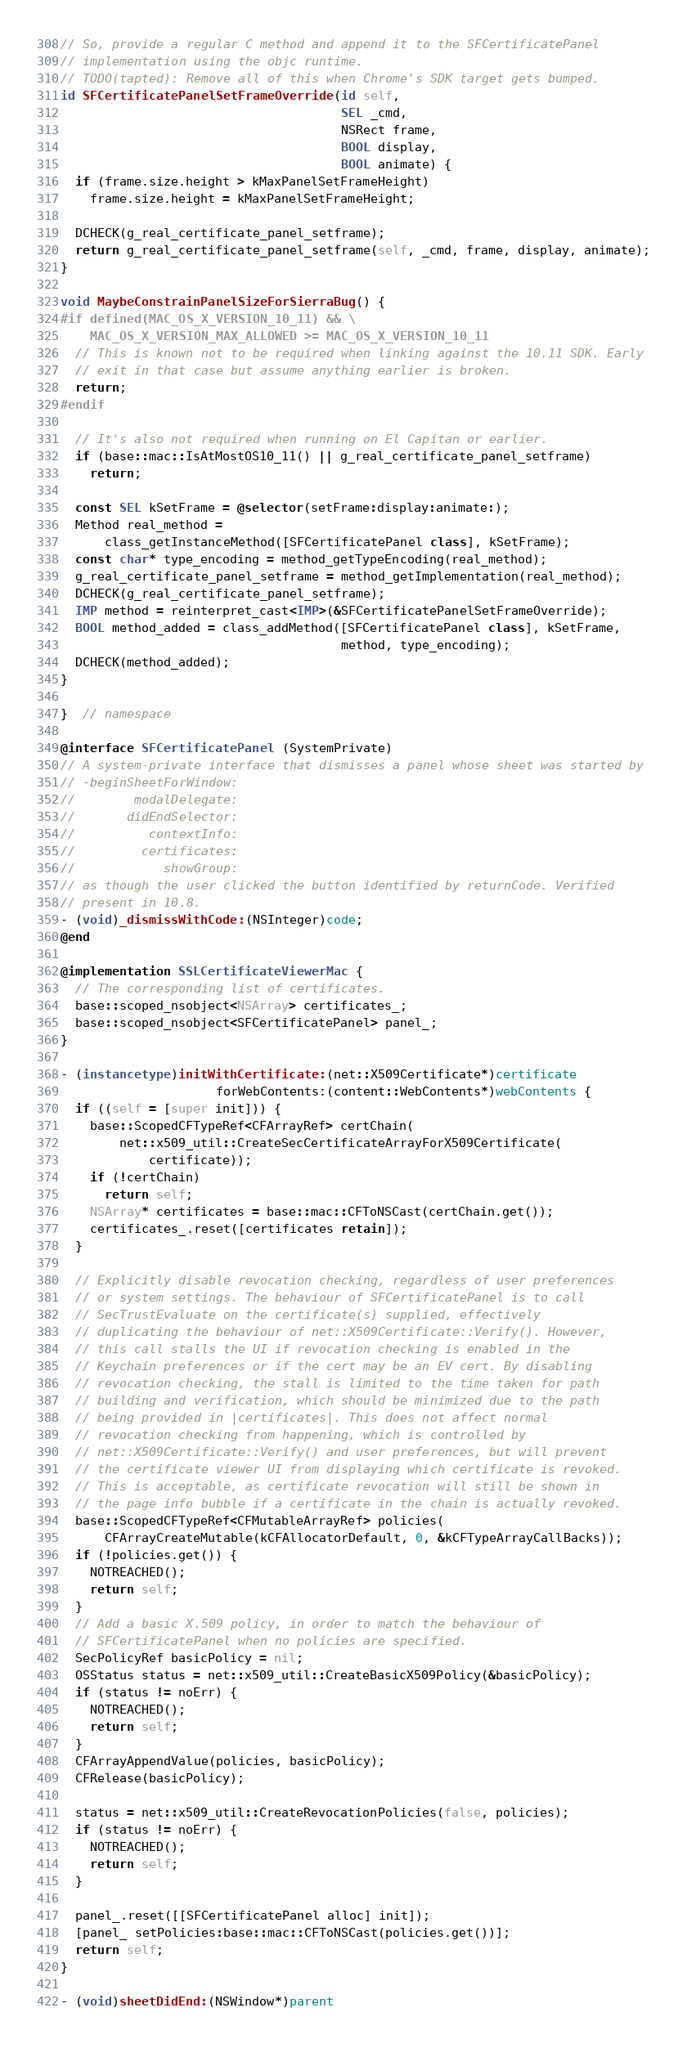Convert code to text. <code><loc_0><loc_0><loc_500><loc_500><_ObjectiveC_>// So, provide a regular C method and append it to the SFCertificatePanel
// implementation using the objc runtime.
// TODO(tapted): Remove all of this when Chrome's SDK target gets bumped.
id SFCertificatePanelSetFrameOverride(id self,
                                      SEL _cmd,
                                      NSRect frame,
                                      BOOL display,
                                      BOOL animate) {
  if (frame.size.height > kMaxPanelSetFrameHeight)
    frame.size.height = kMaxPanelSetFrameHeight;

  DCHECK(g_real_certificate_panel_setframe);
  return g_real_certificate_panel_setframe(self, _cmd, frame, display, animate);
}

void MaybeConstrainPanelSizeForSierraBug() {
#if defined(MAC_OS_X_VERSION_10_11) && \
    MAC_OS_X_VERSION_MAX_ALLOWED >= MAC_OS_X_VERSION_10_11
  // This is known not to be required when linking against the 10.11 SDK. Early
  // exit in that case but assume anything earlier is broken.
  return;
#endif

  // It's also not required when running on El Capitan or earlier.
  if (base::mac::IsAtMostOS10_11() || g_real_certificate_panel_setframe)
    return;

  const SEL kSetFrame = @selector(setFrame:display:animate:);
  Method real_method =
      class_getInstanceMethod([SFCertificatePanel class], kSetFrame);
  const char* type_encoding = method_getTypeEncoding(real_method);
  g_real_certificate_panel_setframe = method_getImplementation(real_method);
  DCHECK(g_real_certificate_panel_setframe);
  IMP method = reinterpret_cast<IMP>(&SFCertificatePanelSetFrameOverride);
  BOOL method_added = class_addMethod([SFCertificatePanel class], kSetFrame,
                                      method, type_encoding);
  DCHECK(method_added);
}

}  // namespace

@interface SFCertificatePanel (SystemPrivate)
// A system-private interface that dismisses a panel whose sheet was started by
// -beginSheetForWindow:
//        modalDelegate:
//       didEndSelector:
//          contextInfo:
//         certificates:
//            showGroup:
// as though the user clicked the button identified by returnCode. Verified
// present in 10.8.
- (void)_dismissWithCode:(NSInteger)code;
@end

@implementation SSLCertificateViewerMac {
  // The corresponding list of certificates.
  base::scoped_nsobject<NSArray> certificates_;
  base::scoped_nsobject<SFCertificatePanel> panel_;
}

- (instancetype)initWithCertificate:(net::X509Certificate*)certificate
                     forWebContents:(content::WebContents*)webContents {
  if ((self = [super init])) {
    base::ScopedCFTypeRef<CFArrayRef> certChain(
        net::x509_util::CreateSecCertificateArrayForX509Certificate(
            certificate));
    if (!certChain)
      return self;
    NSArray* certificates = base::mac::CFToNSCast(certChain.get());
    certificates_.reset([certificates retain]);
  }

  // Explicitly disable revocation checking, regardless of user preferences
  // or system settings. The behaviour of SFCertificatePanel is to call
  // SecTrustEvaluate on the certificate(s) supplied, effectively
  // duplicating the behaviour of net::X509Certificate::Verify(). However,
  // this call stalls the UI if revocation checking is enabled in the
  // Keychain preferences or if the cert may be an EV cert. By disabling
  // revocation checking, the stall is limited to the time taken for path
  // building and verification, which should be minimized due to the path
  // being provided in |certificates|. This does not affect normal
  // revocation checking from happening, which is controlled by
  // net::X509Certificate::Verify() and user preferences, but will prevent
  // the certificate viewer UI from displaying which certificate is revoked.
  // This is acceptable, as certificate revocation will still be shown in
  // the page info bubble if a certificate in the chain is actually revoked.
  base::ScopedCFTypeRef<CFMutableArrayRef> policies(
      CFArrayCreateMutable(kCFAllocatorDefault, 0, &kCFTypeArrayCallBacks));
  if (!policies.get()) {
    NOTREACHED();
    return self;
  }
  // Add a basic X.509 policy, in order to match the behaviour of
  // SFCertificatePanel when no policies are specified.
  SecPolicyRef basicPolicy = nil;
  OSStatus status = net::x509_util::CreateBasicX509Policy(&basicPolicy);
  if (status != noErr) {
    NOTREACHED();
    return self;
  }
  CFArrayAppendValue(policies, basicPolicy);
  CFRelease(basicPolicy);

  status = net::x509_util::CreateRevocationPolicies(false, policies);
  if (status != noErr) {
    NOTREACHED();
    return self;
  }

  panel_.reset([[SFCertificatePanel alloc] init]);
  [panel_ setPolicies:base::mac::CFToNSCast(policies.get())];
  return self;
}

- (void)sheetDidEnd:(NSWindow*)parent</code> 